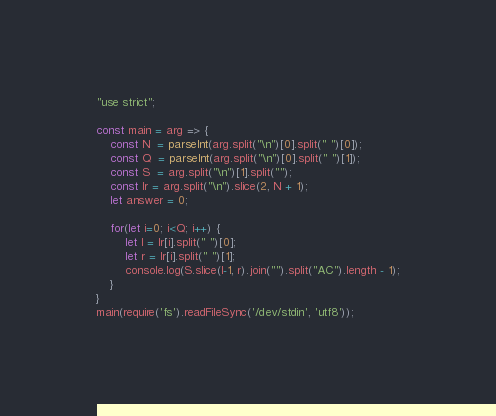Convert code to text. <code><loc_0><loc_0><loc_500><loc_500><_JavaScript_>"use strict";
    
const main = arg => {
    const N  = parseInt(arg.split("\n")[0].split(" ")[0]);
    const Q  = parseInt(arg.split("\n")[0].split(" ")[1]);
    const S  = arg.split("\n")[1].split("");
    const lr = arg.split("\n").slice(2, N + 1);
    let answer = 0;
    
    for(let i=0; i<Q; i++) {
        let l = lr[i].split(" ")[0];
        let r = lr[i].split(" ")[1];
        console.log(S.slice(l-1, r).join("").split("AC").length - 1);
    }
}
main(require('fs').readFileSync('/dev/stdin', 'utf8'));</code> 